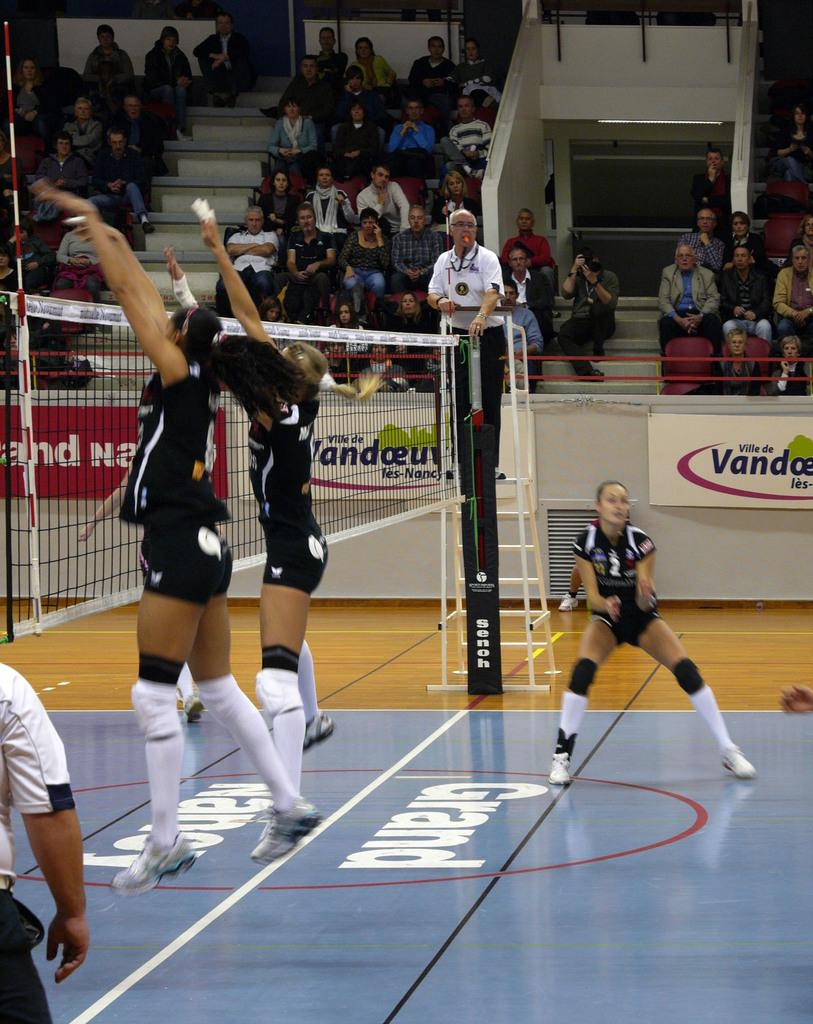<image>
Render a clear and concise summary of the photo. Volleyball players on a court sponsored by Vandceuv. 